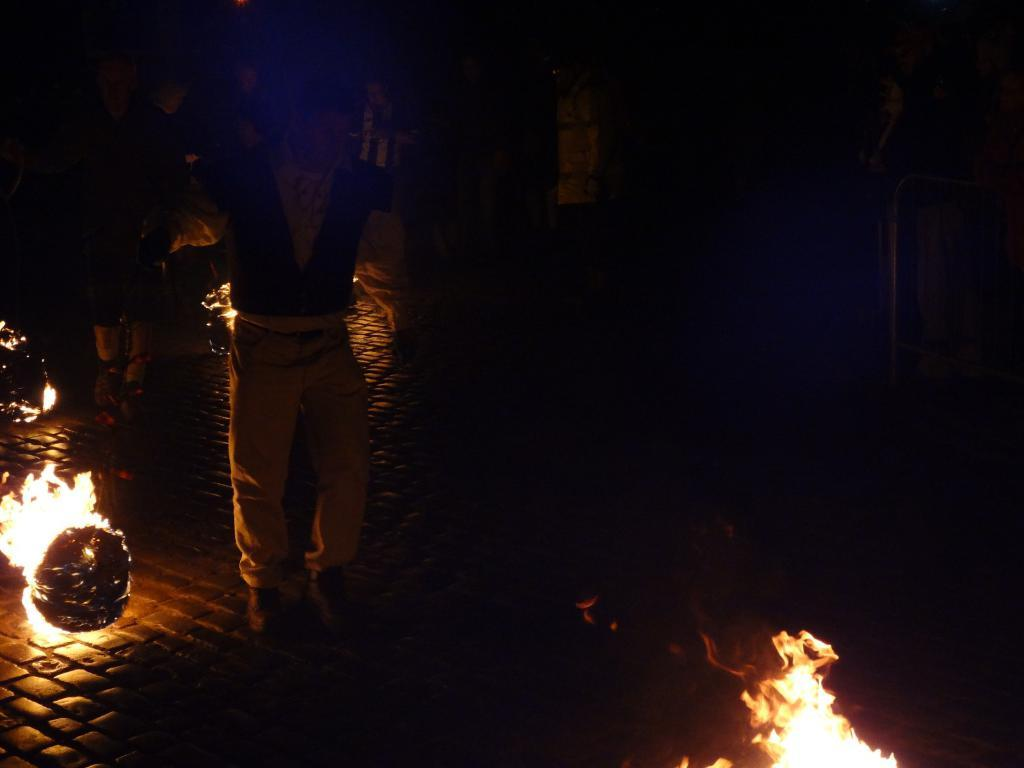What is present in the image? There is a person in the image. Can you describe the person's attire? The person is wearing clothes and shoes. What can be seen in the image besides the person? There is a flame and a footpath in the image. How many children are playing with the sheet in the image? There is no sheet or children present in the image. 